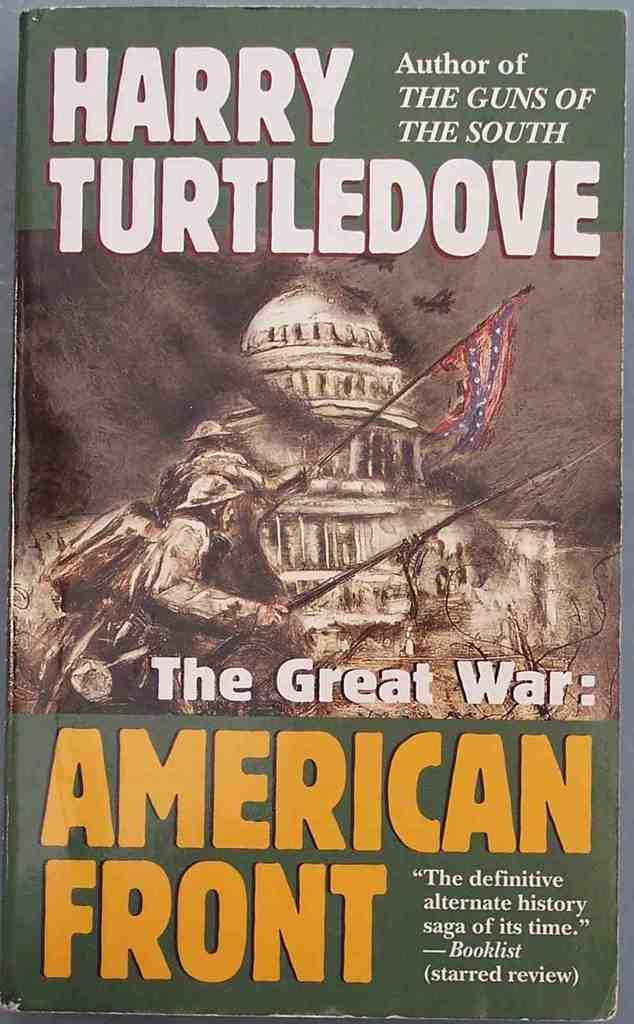Provide a one-sentence caption for the provided image. The cover of a book by Harry Turtledove features the title "The Great War: American Front.". 